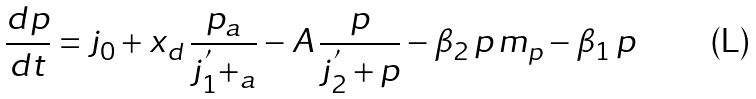<formula> <loc_0><loc_0><loc_500><loc_500>\frac { d p } { d t } = j _ { 0 } + x _ { d } \, \frac { p _ { a } } { j _ { 1 } ^ { ^ { \prime } } + _ { a } } - A \, \frac { p } { j _ { 2 } ^ { ^ { \prime } } + p } - \beta _ { 2 } \, p \, m _ { p } - \beta _ { 1 } \, p</formula> 